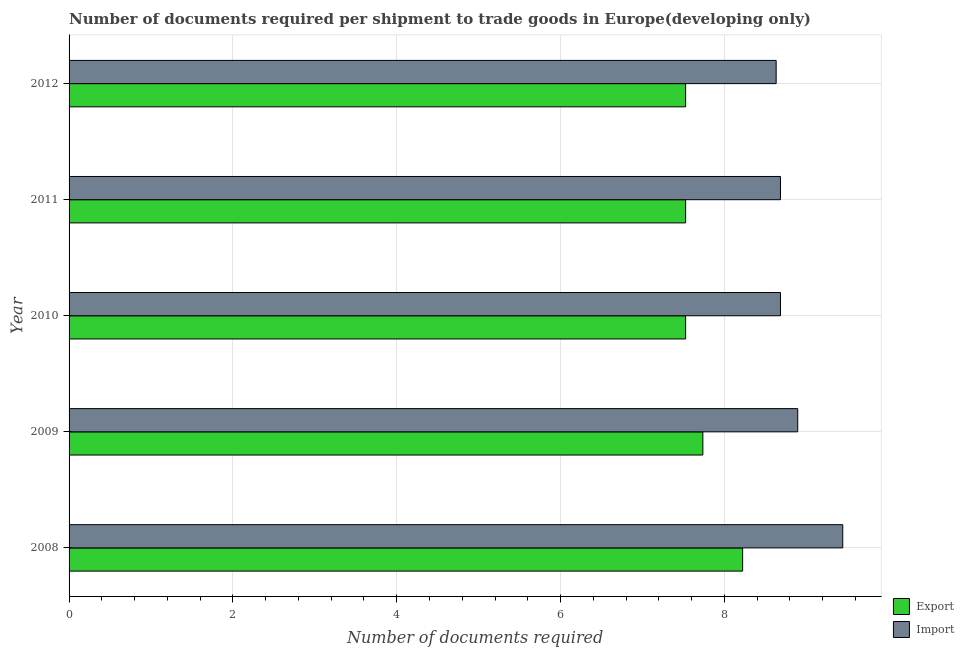How many groups of bars are there?
Provide a short and direct response. 5. Are the number of bars on each tick of the Y-axis equal?
Provide a succinct answer. Yes. How many bars are there on the 5th tick from the bottom?
Your response must be concise. 2. What is the number of documents required to export goods in 2011?
Ensure brevity in your answer.  7.53. Across all years, what is the maximum number of documents required to export goods?
Keep it short and to the point. 8.22. Across all years, what is the minimum number of documents required to import goods?
Ensure brevity in your answer.  8.63. In which year was the number of documents required to import goods minimum?
Provide a short and direct response. 2012. What is the total number of documents required to import goods in the graph?
Your answer should be very brief. 44.34. What is the difference between the number of documents required to import goods in 2009 and that in 2011?
Provide a succinct answer. 0.21. What is the difference between the number of documents required to export goods in 2008 and the number of documents required to import goods in 2010?
Give a very brief answer. -0.46. What is the average number of documents required to import goods per year?
Your answer should be compact. 8.87. In the year 2011, what is the difference between the number of documents required to export goods and number of documents required to import goods?
Your answer should be compact. -1.16. What is the ratio of the number of documents required to import goods in 2009 to that in 2012?
Give a very brief answer. 1.03. What is the difference between the highest and the second highest number of documents required to import goods?
Give a very brief answer. 0.55. What is the difference between the highest and the lowest number of documents required to import goods?
Your answer should be very brief. 0.81. In how many years, is the number of documents required to export goods greater than the average number of documents required to export goods taken over all years?
Give a very brief answer. 2. Is the sum of the number of documents required to export goods in 2008 and 2011 greater than the maximum number of documents required to import goods across all years?
Give a very brief answer. Yes. What does the 2nd bar from the top in 2011 represents?
Provide a succinct answer. Export. What does the 1st bar from the bottom in 2010 represents?
Offer a terse response. Export. How many bars are there?
Provide a succinct answer. 10. Are all the bars in the graph horizontal?
Provide a succinct answer. Yes. Are the values on the major ticks of X-axis written in scientific E-notation?
Give a very brief answer. No. Does the graph contain any zero values?
Your answer should be very brief. No. Does the graph contain grids?
Keep it short and to the point. Yes. Where does the legend appear in the graph?
Give a very brief answer. Bottom right. What is the title of the graph?
Provide a short and direct response. Number of documents required per shipment to trade goods in Europe(developing only). What is the label or title of the X-axis?
Offer a very short reply. Number of documents required. What is the label or title of the Y-axis?
Give a very brief answer. Year. What is the Number of documents required of Export in 2008?
Keep it short and to the point. 8.22. What is the Number of documents required of Import in 2008?
Provide a succinct answer. 9.44. What is the Number of documents required in Export in 2009?
Your response must be concise. 7.74. What is the Number of documents required of Import in 2009?
Make the answer very short. 8.89. What is the Number of documents required of Export in 2010?
Your response must be concise. 7.53. What is the Number of documents required of Import in 2010?
Your answer should be very brief. 8.68. What is the Number of documents required in Export in 2011?
Make the answer very short. 7.53. What is the Number of documents required of Import in 2011?
Your response must be concise. 8.68. What is the Number of documents required in Export in 2012?
Keep it short and to the point. 7.53. What is the Number of documents required in Import in 2012?
Ensure brevity in your answer.  8.63. Across all years, what is the maximum Number of documents required in Export?
Offer a very short reply. 8.22. Across all years, what is the maximum Number of documents required in Import?
Your answer should be compact. 9.44. Across all years, what is the minimum Number of documents required in Export?
Your answer should be compact. 7.53. Across all years, what is the minimum Number of documents required of Import?
Give a very brief answer. 8.63. What is the total Number of documents required of Export in the graph?
Your response must be concise. 38.54. What is the total Number of documents required in Import in the graph?
Make the answer very short. 44.34. What is the difference between the Number of documents required in Export in 2008 and that in 2009?
Your answer should be very brief. 0.49. What is the difference between the Number of documents required of Import in 2008 and that in 2009?
Give a very brief answer. 0.55. What is the difference between the Number of documents required in Export in 2008 and that in 2010?
Provide a short and direct response. 0.7. What is the difference between the Number of documents required of Import in 2008 and that in 2010?
Make the answer very short. 0.76. What is the difference between the Number of documents required of Export in 2008 and that in 2011?
Provide a succinct answer. 0.7. What is the difference between the Number of documents required of Import in 2008 and that in 2011?
Your response must be concise. 0.76. What is the difference between the Number of documents required of Export in 2008 and that in 2012?
Make the answer very short. 0.7. What is the difference between the Number of documents required in Import in 2008 and that in 2012?
Your answer should be very brief. 0.81. What is the difference between the Number of documents required in Export in 2009 and that in 2010?
Offer a very short reply. 0.21. What is the difference between the Number of documents required of Import in 2009 and that in 2010?
Keep it short and to the point. 0.21. What is the difference between the Number of documents required in Export in 2009 and that in 2011?
Provide a succinct answer. 0.21. What is the difference between the Number of documents required in Import in 2009 and that in 2011?
Provide a short and direct response. 0.21. What is the difference between the Number of documents required of Export in 2009 and that in 2012?
Give a very brief answer. 0.21. What is the difference between the Number of documents required of Import in 2009 and that in 2012?
Give a very brief answer. 0.26. What is the difference between the Number of documents required of Export in 2010 and that in 2011?
Provide a succinct answer. 0. What is the difference between the Number of documents required of Import in 2010 and that in 2011?
Keep it short and to the point. 0. What is the difference between the Number of documents required of Import in 2010 and that in 2012?
Keep it short and to the point. 0.05. What is the difference between the Number of documents required in Import in 2011 and that in 2012?
Your response must be concise. 0.05. What is the difference between the Number of documents required of Export in 2008 and the Number of documents required of Import in 2009?
Give a very brief answer. -0.67. What is the difference between the Number of documents required of Export in 2008 and the Number of documents required of Import in 2010?
Ensure brevity in your answer.  -0.46. What is the difference between the Number of documents required in Export in 2008 and the Number of documents required in Import in 2011?
Offer a terse response. -0.46. What is the difference between the Number of documents required in Export in 2008 and the Number of documents required in Import in 2012?
Provide a short and direct response. -0.41. What is the difference between the Number of documents required in Export in 2009 and the Number of documents required in Import in 2010?
Give a very brief answer. -0.95. What is the difference between the Number of documents required of Export in 2009 and the Number of documents required of Import in 2011?
Provide a succinct answer. -0.95. What is the difference between the Number of documents required of Export in 2009 and the Number of documents required of Import in 2012?
Offer a terse response. -0.89. What is the difference between the Number of documents required of Export in 2010 and the Number of documents required of Import in 2011?
Your answer should be very brief. -1.16. What is the difference between the Number of documents required of Export in 2010 and the Number of documents required of Import in 2012?
Provide a succinct answer. -1.11. What is the difference between the Number of documents required of Export in 2011 and the Number of documents required of Import in 2012?
Provide a short and direct response. -1.11. What is the average Number of documents required in Export per year?
Provide a succinct answer. 7.71. What is the average Number of documents required of Import per year?
Your response must be concise. 8.87. In the year 2008, what is the difference between the Number of documents required of Export and Number of documents required of Import?
Give a very brief answer. -1.22. In the year 2009, what is the difference between the Number of documents required in Export and Number of documents required in Import?
Keep it short and to the point. -1.16. In the year 2010, what is the difference between the Number of documents required of Export and Number of documents required of Import?
Your answer should be very brief. -1.16. In the year 2011, what is the difference between the Number of documents required in Export and Number of documents required in Import?
Your response must be concise. -1.16. In the year 2012, what is the difference between the Number of documents required of Export and Number of documents required of Import?
Make the answer very short. -1.11. What is the ratio of the Number of documents required of Export in 2008 to that in 2009?
Your response must be concise. 1.06. What is the ratio of the Number of documents required of Import in 2008 to that in 2009?
Ensure brevity in your answer.  1.06. What is the ratio of the Number of documents required of Export in 2008 to that in 2010?
Keep it short and to the point. 1.09. What is the ratio of the Number of documents required of Import in 2008 to that in 2010?
Provide a short and direct response. 1.09. What is the ratio of the Number of documents required of Export in 2008 to that in 2011?
Offer a terse response. 1.09. What is the ratio of the Number of documents required in Import in 2008 to that in 2011?
Offer a very short reply. 1.09. What is the ratio of the Number of documents required of Export in 2008 to that in 2012?
Provide a short and direct response. 1.09. What is the ratio of the Number of documents required of Import in 2008 to that in 2012?
Keep it short and to the point. 1.09. What is the ratio of the Number of documents required in Export in 2009 to that in 2010?
Provide a succinct answer. 1.03. What is the ratio of the Number of documents required of Import in 2009 to that in 2010?
Provide a succinct answer. 1.02. What is the ratio of the Number of documents required in Export in 2009 to that in 2011?
Your answer should be very brief. 1.03. What is the ratio of the Number of documents required of Import in 2009 to that in 2011?
Offer a very short reply. 1.02. What is the ratio of the Number of documents required in Export in 2009 to that in 2012?
Your response must be concise. 1.03. What is the ratio of the Number of documents required of Import in 2009 to that in 2012?
Make the answer very short. 1.03. What is the ratio of the Number of documents required of Export in 2010 to that in 2011?
Make the answer very short. 1. What is the ratio of the Number of documents required in Import in 2010 to that in 2011?
Your response must be concise. 1. What is the ratio of the Number of documents required in Export in 2011 to that in 2012?
Ensure brevity in your answer.  1. What is the ratio of the Number of documents required of Import in 2011 to that in 2012?
Your response must be concise. 1.01. What is the difference between the highest and the second highest Number of documents required in Export?
Offer a terse response. 0.49. What is the difference between the highest and the second highest Number of documents required of Import?
Your answer should be compact. 0.55. What is the difference between the highest and the lowest Number of documents required of Export?
Provide a succinct answer. 0.7. What is the difference between the highest and the lowest Number of documents required of Import?
Ensure brevity in your answer.  0.81. 